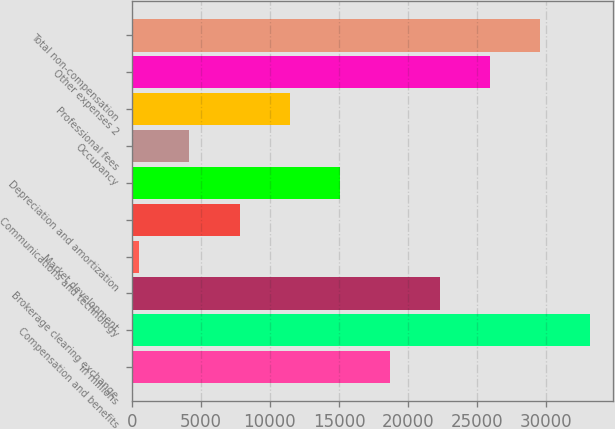Convert chart to OTSL. <chart><loc_0><loc_0><loc_500><loc_500><bar_chart><fcel>in millions<fcel>Compensation and benefits<fcel>Brokerage clearing exchange<fcel>Market development<fcel>Communications and technology<fcel>Depreciation and amortization<fcel>Occupancy<fcel>Professional fees<fcel>Other expenses 2<fcel>Total non-compensation<nl><fcel>18678.5<fcel>33175.7<fcel>22302.8<fcel>557<fcel>7805.6<fcel>15054.2<fcel>4181.3<fcel>11429.9<fcel>25927.1<fcel>29551.4<nl></chart> 